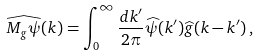<formula> <loc_0><loc_0><loc_500><loc_500>\widehat { M _ { g } \psi } ( k ) = \int _ { 0 } ^ { \infty } \frac { d k ^ { \prime } } { 2 \pi } \widehat { \psi } ( k ^ { \prime } ) \widehat { g } ( k - k ^ { \prime } ) \, ,</formula> 